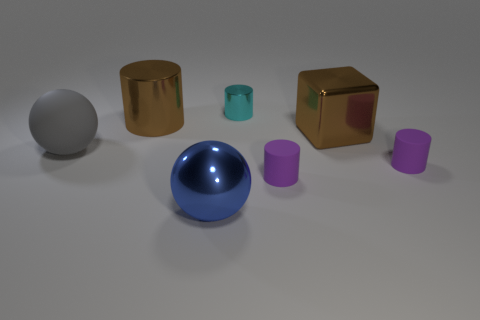Add 3 big blue metallic cylinders. How many objects exist? 10 Subtract all balls. How many objects are left? 5 Add 3 gray balls. How many gray balls are left? 4 Add 7 big yellow cylinders. How many big yellow cylinders exist? 7 Subtract all brown cylinders. How many cylinders are left? 3 Subtract all small metallic cylinders. How many cylinders are left? 3 Subtract 0 purple cubes. How many objects are left? 7 Subtract 4 cylinders. How many cylinders are left? 0 Subtract all red blocks. Subtract all brown cylinders. How many blocks are left? 1 Subtract all blue cylinders. How many blue spheres are left? 1 